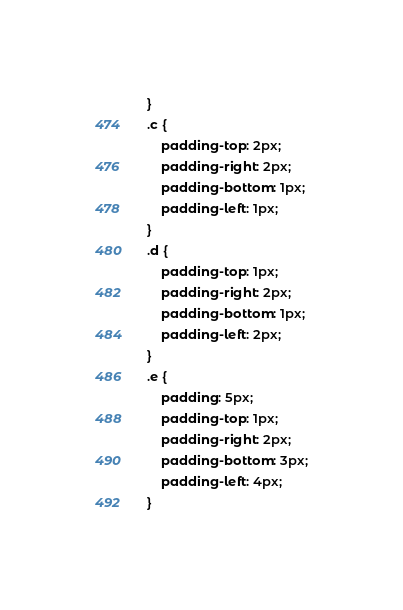Convert code to text. <code><loc_0><loc_0><loc_500><loc_500><_CSS_>}
.c {
    padding-top: 2px;
    padding-right: 2px;
    padding-bottom: 1px;
    padding-left: 1px;
}
.d {
    padding-top: 1px;
    padding-right: 2px;
    padding-bottom: 1px;
    padding-left: 2px;
}
.e {
    padding: 5px;
    padding-top: 1px;
    padding-right: 2px;
    padding-bottom: 3px;
    padding-left: 4px;
}
</code> 